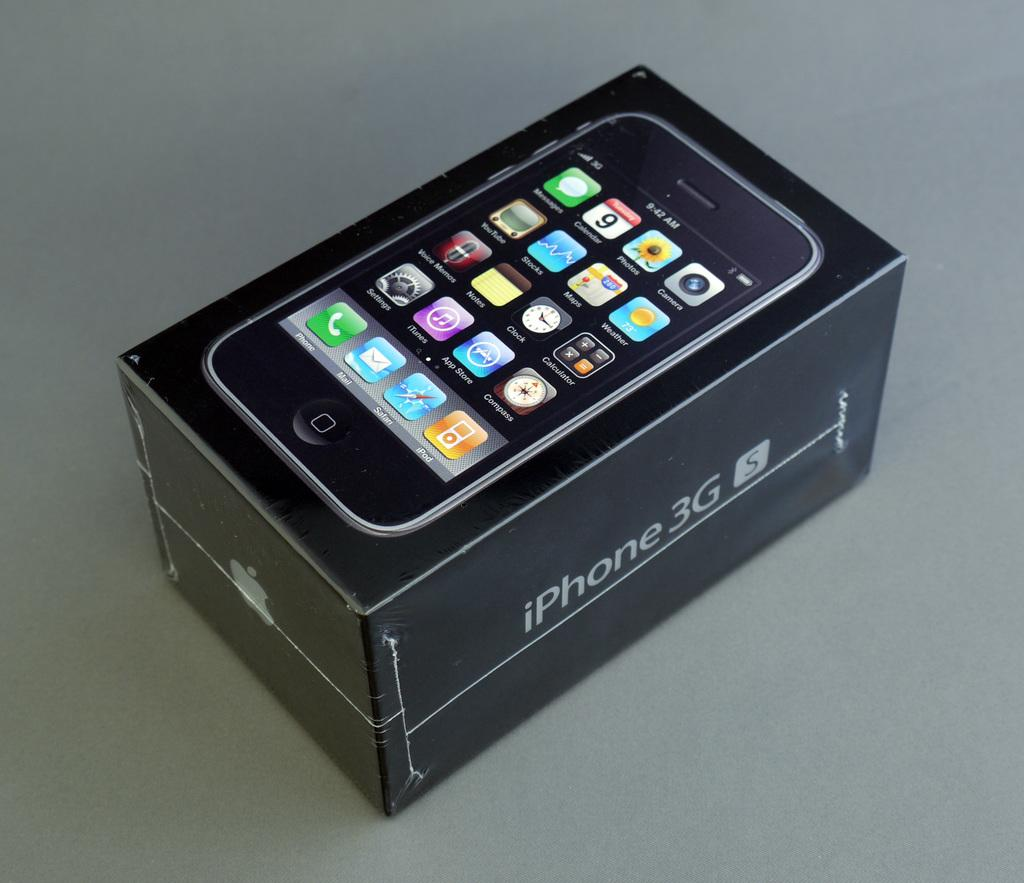<image>
Write a terse but informative summary of the picture. Black box for a cellphone that says iPhone 3g on the side. 